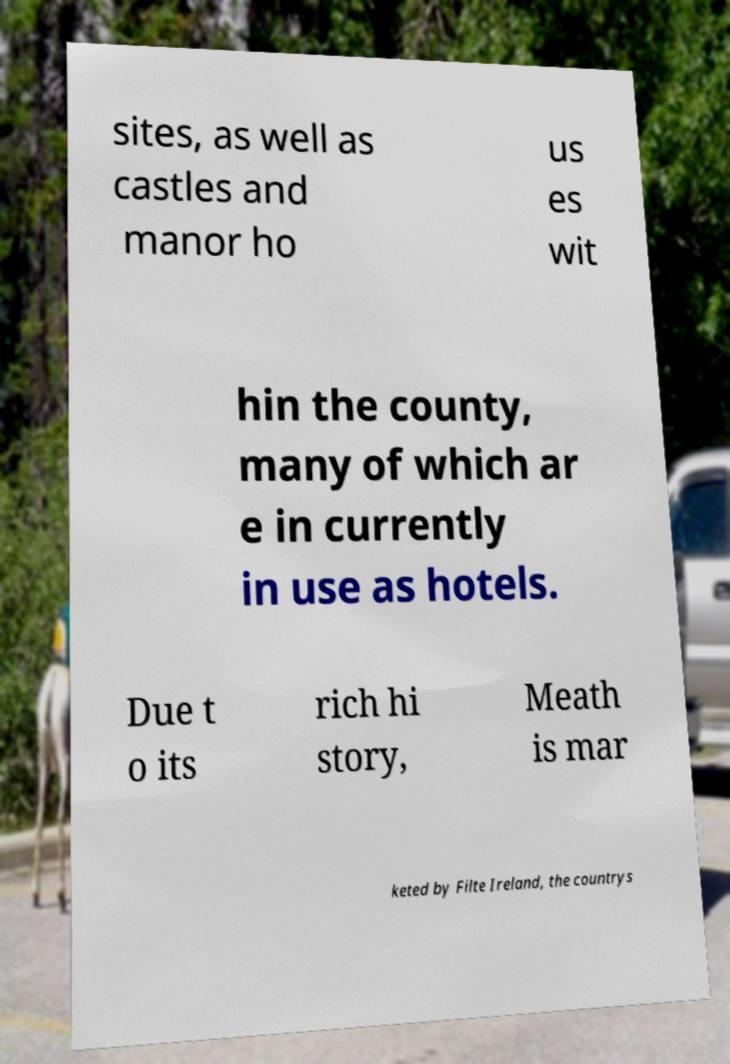Can you read and provide the text displayed in the image?This photo seems to have some interesting text. Can you extract and type it out for me? sites, as well as castles and manor ho us es wit hin the county, many of which ar e in currently in use as hotels. Due t o its rich hi story, Meath is mar keted by Filte Ireland, the countrys 